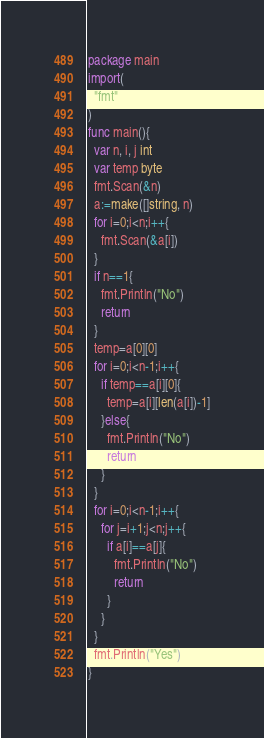Convert code to text. <code><loc_0><loc_0><loc_500><loc_500><_Go_>package main
import(
  "fmt"
)
func main(){
  var n, i, j int
  var temp byte
  fmt.Scan(&n)
  a:=make([]string, n)
  for i=0;i<n;i++{
    fmt.Scan(&a[i])
  }
  if n==1{
    fmt.Println("No")
    return
  }
  temp=a[0][0]
  for i=0;i<n-1;i++{
    if temp==a[i][0]{
      temp=a[i][len(a[i])-1]
    }else{
      fmt.Println("No")
      return
    }
  }
  for i=0;i<n-1;i++{
    for j=i+1;j<n;j++{
      if a[i]==a[j]{
        fmt.Println("No")
        return
      }
    }
  }
  fmt.Println("Yes")
}
</code> 